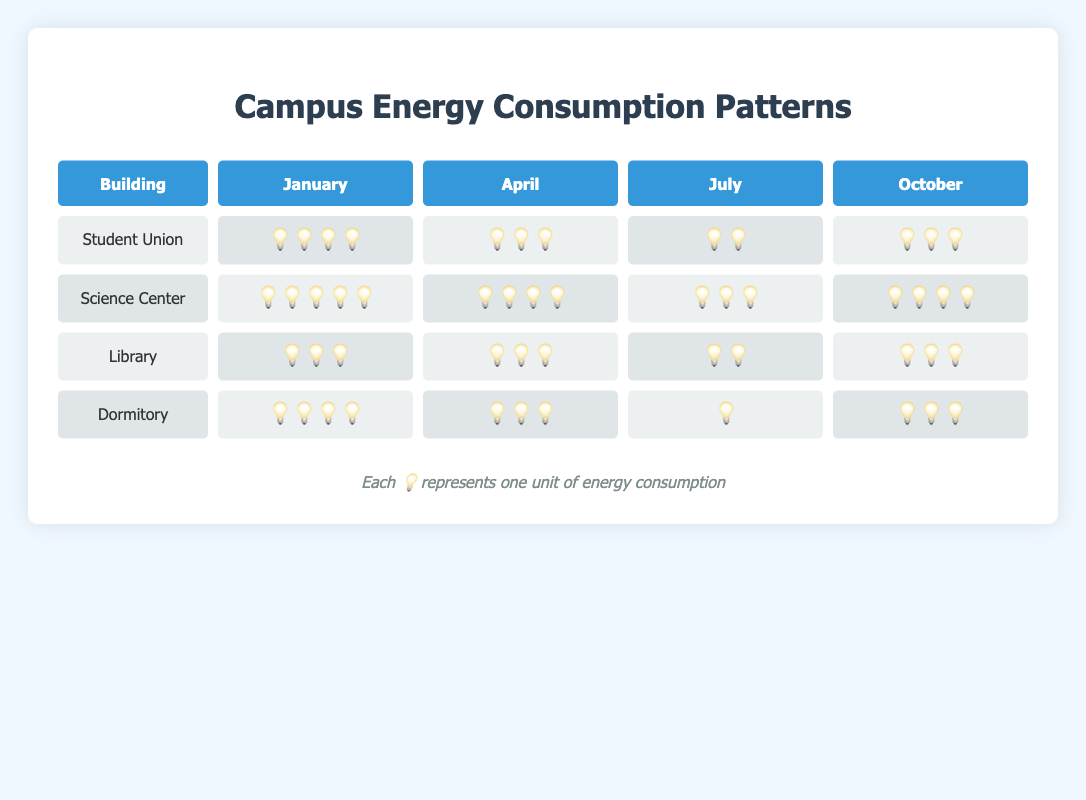What is the title of the chart? The title is clearly displayed at the top of the chart, which provides an overview of what the chart is about.
Answer: Campus Energy Consumption Patterns How many times does the Student Union have 3 light bulbs of usage? Checking each month for the Student Union's row, it has 3 light bulbs in April and October.
Answer: 2 times Which building has the highest energy consumption in January? By comparing the quantity of light bulbs in January for all buildings, the Science Center has the most with 5 bulbs.
Answer: Science Center What is the average energy usage for the Dormitory throughout the year (average number of light bulbs)? Adding the number of light bulbs for each month and dividing by 4, (4+3+1+3)/4 = 11/4 = 2.75.
Answer: 2.75 Which month shows the lowest energy consumption for the Library? Examining the Library's energy consumption in each month, July shows the lowest with 2 light bulbs.
Answer: July Compare the energy consumption between the Science Center and the Library in April. Which one is higher and by how much? The Science Center has 4 light bulbs in April, whereas the Library has 3 light bulbs. The difference is 4 - 3 = 1 light bulb.
Answer: Science Center, 1 light bulb What is the total energy consumption for all buildings in October? Adding the total light bulbs for October across all buildings: 3 (Student Union) + 4 (Science Center) + 3 (Library) + 3 (Dormitory) = 13.
Answer: 13 In which month does the Student Union have a usage pattern of 2 light bulbs? From the usage data, in July, the Student Union shows a consumption pattern of 2 light bulbs.
Answer: July Identify the building with the most variable energy consumption patterns throughout the year. By comparing the variations (difference between months) in light bulbs, the Dormitory has the widest range, from 1 (July) to 4 (January).
Answer: Dormitory What is the approximate overall energy consumption for the Science Center across all months? Summing up the light bulbs for the Science Center across all months: 5 (January) + 4 (April) + 3 (July) + 4 (October) = 16.
Answer: 16 